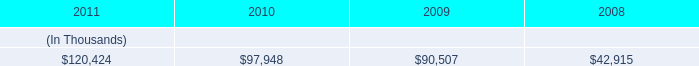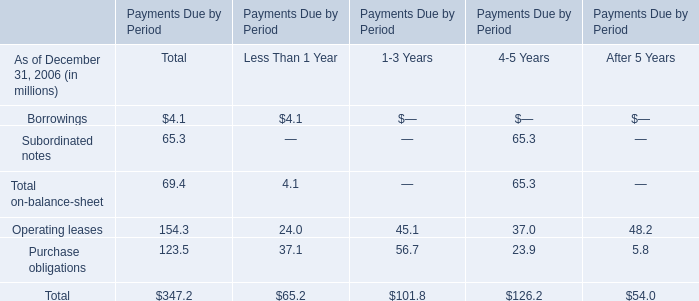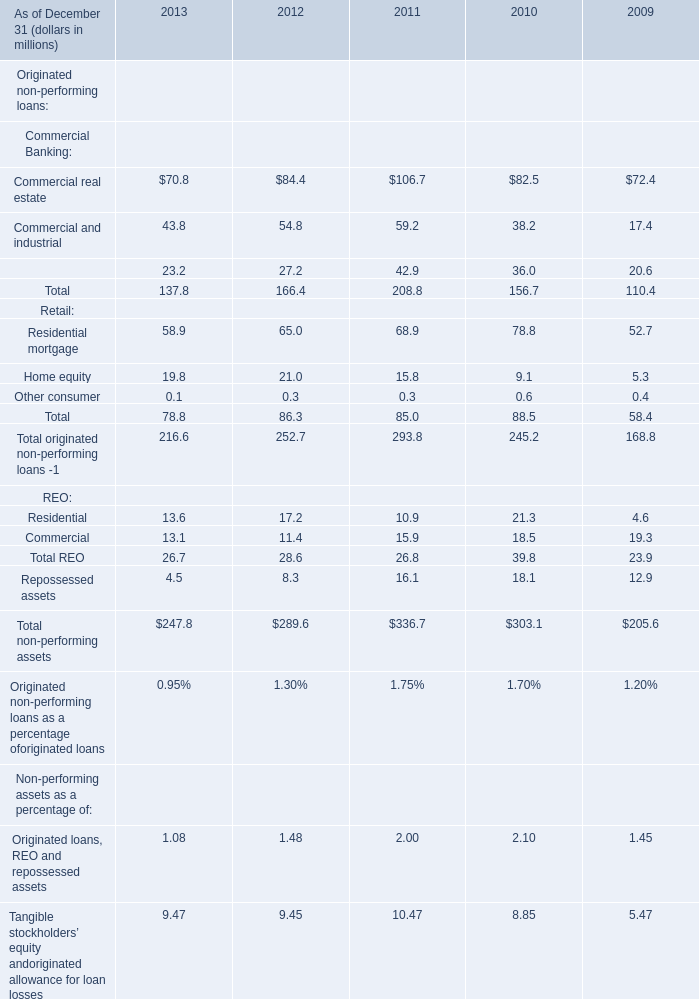What is the ratio of all retail that are smaller than 60 to the sum of retail, in 2011? (in %) 
Computations: ((15.8 + 0.3) / 85)
Answer: 0.18941. 